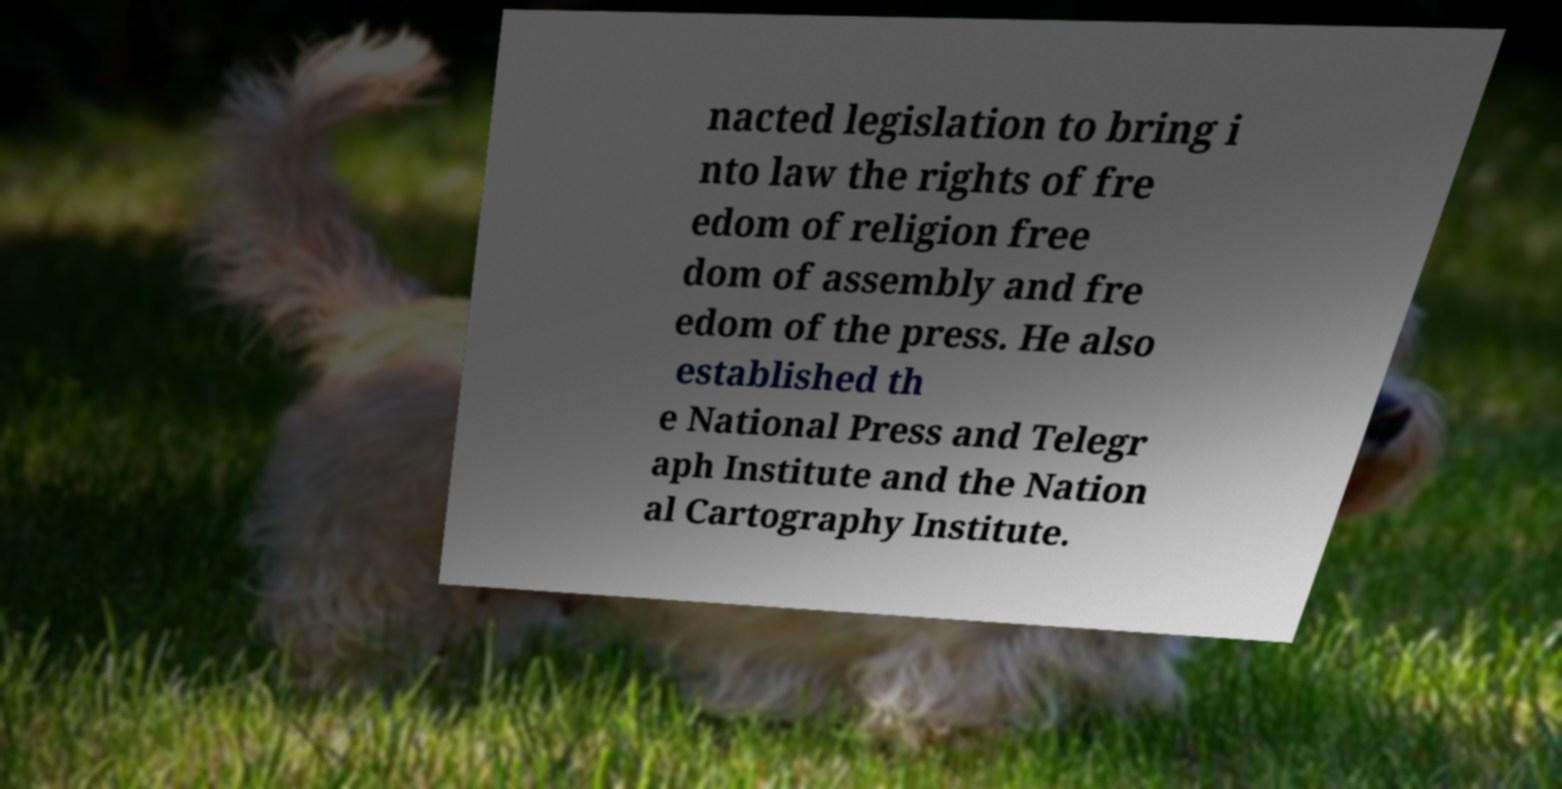Please read and relay the text visible in this image. What does it say? nacted legislation to bring i nto law the rights of fre edom of religion free dom of assembly and fre edom of the press. He also established th e National Press and Telegr aph Institute and the Nation al Cartography Institute. 